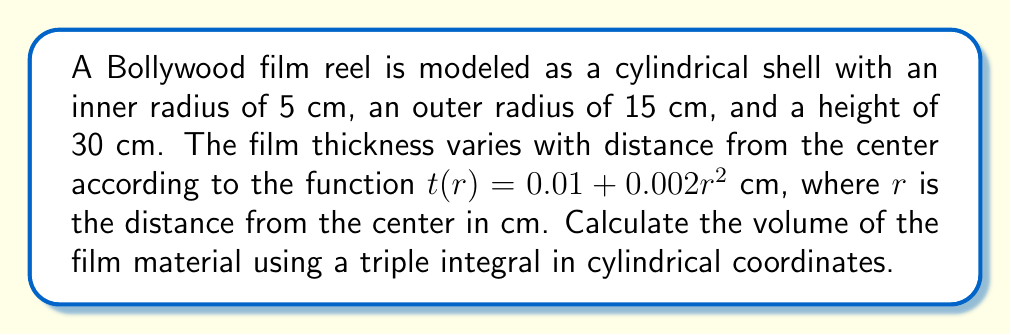Show me your answer to this math problem. Let's approach this step-by-step:

1) In cylindrical coordinates, we have:
   $r$: distance from the center
   $\theta$: angle in the xy-plane
   $z$: height

2) The volume element in cylindrical coordinates is:
   $$dV = r \, dr \, d\theta \, dz$$

3) The limits of integration are:
   $5 \leq r \leq 15$ (from inner to outer radius)
   $0 \leq \theta \leq 2\pi$ (full rotation)
   $0 \leq z \leq 30$ (height of the reel)

4) The thickness function $t(r)$ represents the volume we want to integrate over each infinitesimal element. So our triple integral is:

   $$V = \int_0^{30} \int_0^{2\pi} \int_5^{15} t(r) \, r \, dr \, d\theta \, dz$$

5) Substituting $t(r) = 0.01 + 0.002r^2$:

   $$V = \int_0^{30} \int_0^{2\pi} \int_5^{15} (0.01 + 0.002r^2) \, r \, dr \, d\theta \, dz$$

6) Integrate with respect to $r$:
   $$V = \int_0^{30} \int_0^{2\pi} \left[0.01\frac{r^2}{2} + 0.002\frac{r^4}{4}\right]_5^{15} \, d\theta \, dz$$

7) Evaluate the inner integral:
   $$V = \int_0^{30} \int_0^{2\pi} \left(0.005(225-25) + 0.0005(50625-625)\right) \, d\theta \, dz$$
   $$= \int_0^{30} \int_0^{2\pi} (1 + 25) \, d\theta \, dz = \int_0^{30} \int_0^{2\pi} 26 \, d\theta \, dz$$

8) Integrate with respect to $\theta$:
   $$V = \int_0^{30} 26 \cdot 2\pi \, dz = 52\pi \int_0^{30} dz$$

9) Integrate with respect to $z$:
   $$V = 52\pi \cdot 30 = 1560\pi \text{ cm}^3$$
Answer: $1560\pi \text{ cm}^3$ 